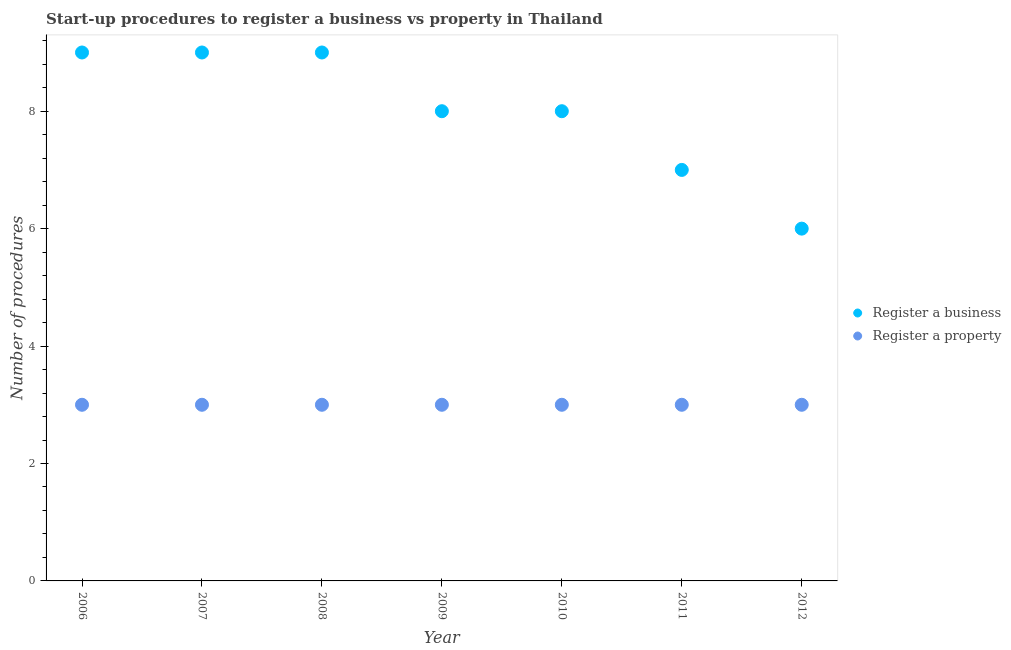What is the number of procedures to register a business in 2009?
Make the answer very short. 8. Across all years, what is the maximum number of procedures to register a property?
Ensure brevity in your answer.  3. Across all years, what is the minimum number of procedures to register a property?
Give a very brief answer. 3. In which year was the number of procedures to register a business maximum?
Provide a short and direct response. 2006. What is the total number of procedures to register a business in the graph?
Offer a terse response. 56. What is the difference between the number of procedures to register a business in 2008 and that in 2012?
Ensure brevity in your answer.  3. What is the difference between the number of procedures to register a property in 2007 and the number of procedures to register a business in 2006?
Keep it short and to the point. -6. In the year 2011, what is the difference between the number of procedures to register a business and number of procedures to register a property?
Ensure brevity in your answer.  4. In how many years, is the number of procedures to register a business greater than 7.6?
Keep it short and to the point. 5. What is the ratio of the number of procedures to register a business in 2010 to that in 2012?
Offer a terse response. 1.33. Is the number of procedures to register a business in 2007 less than that in 2008?
Make the answer very short. No. Is the difference between the number of procedures to register a business in 2006 and 2012 greater than the difference between the number of procedures to register a property in 2006 and 2012?
Your response must be concise. Yes. What is the difference between the highest and the second highest number of procedures to register a business?
Keep it short and to the point. 0. What is the difference between the highest and the lowest number of procedures to register a property?
Your answer should be compact. 0. In how many years, is the number of procedures to register a property greater than the average number of procedures to register a property taken over all years?
Your answer should be compact. 0. Is the sum of the number of procedures to register a property in 2008 and 2010 greater than the maximum number of procedures to register a business across all years?
Keep it short and to the point. No. Is the number of procedures to register a business strictly greater than the number of procedures to register a property over the years?
Make the answer very short. Yes. Is the number of procedures to register a property strictly less than the number of procedures to register a business over the years?
Your answer should be compact. Yes. How many dotlines are there?
Keep it short and to the point. 2. What is the difference between two consecutive major ticks on the Y-axis?
Ensure brevity in your answer.  2. Are the values on the major ticks of Y-axis written in scientific E-notation?
Give a very brief answer. No. Does the graph contain grids?
Keep it short and to the point. No. How many legend labels are there?
Your response must be concise. 2. How are the legend labels stacked?
Your answer should be very brief. Vertical. What is the title of the graph?
Your response must be concise. Start-up procedures to register a business vs property in Thailand. Does "Private creditors" appear as one of the legend labels in the graph?
Provide a short and direct response. No. What is the label or title of the Y-axis?
Provide a short and direct response. Number of procedures. What is the Number of procedures of Register a business in 2006?
Provide a succinct answer. 9. What is the Number of procedures of Register a property in 2007?
Offer a very short reply. 3. What is the Number of procedures of Register a business in 2008?
Your answer should be compact. 9. What is the Number of procedures in Register a property in 2009?
Ensure brevity in your answer.  3. What is the Number of procedures in Register a business in 2010?
Make the answer very short. 8. What is the Number of procedures in Register a property in 2010?
Keep it short and to the point. 3. What is the Number of procedures of Register a business in 2011?
Make the answer very short. 7. What is the Number of procedures of Register a property in 2012?
Your response must be concise. 3. Across all years, what is the maximum Number of procedures of Register a business?
Keep it short and to the point. 9. Across all years, what is the maximum Number of procedures of Register a property?
Make the answer very short. 3. Across all years, what is the minimum Number of procedures in Register a business?
Your response must be concise. 6. What is the total Number of procedures in Register a business in the graph?
Your answer should be very brief. 56. What is the total Number of procedures in Register a property in the graph?
Make the answer very short. 21. What is the difference between the Number of procedures in Register a property in 2006 and that in 2007?
Offer a very short reply. 0. What is the difference between the Number of procedures of Register a business in 2006 and that in 2008?
Ensure brevity in your answer.  0. What is the difference between the Number of procedures in Register a property in 2006 and that in 2008?
Your answer should be compact. 0. What is the difference between the Number of procedures in Register a business in 2006 and that in 2009?
Offer a terse response. 1. What is the difference between the Number of procedures in Register a property in 2006 and that in 2009?
Your answer should be compact. 0. What is the difference between the Number of procedures in Register a property in 2006 and that in 2010?
Your answer should be very brief. 0. What is the difference between the Number of procedures in Register a business in 2007 and that in 2008?
Give a very brief answer. 0. What is the difference between the Number of procedures in Register a property in 2007 and that in 2010?
Keep it short and to the point. 0. What is the difference between the Number of procedures of Register a property in 2007 and that in 2011?
Your response must be concise. 0. What is the difference between the Number of procedures of Register a business in 2008 and that in 2010?
Your answer should be compact. 1. What is the difference between the Number of procedures of Register a business in 2008 and that in 2011?
Your answer should be very brief. 2. What is the difference between the Number of procedures in Register a business in 2008 and that in 2012?
Keep it short and to the point. 3. What is the difference between the Number of procedures of Register a property in 2008 and that in 2012?
Provide a short and direct response. 0. What is the difference between the Number of procedures of Register a business in 2009 and that in 2010?
Ensure brevity in your answer.  0. What is the difference between the Number of procedures in Register a property in 2009 and that in 2010?
Make the answer very short. 0. What is the difference between the Number of procedures of Register a property in 2009 and that in 2011?
Offer a very short reply. 0. What is the difference between the Number of procedures of Register a business in 2009 and that in 2012?
Offer a very short reply. 2. What is the difference between the Number of procedures in Register a property in 2010 and that in 2011?
Make the answer very short. 0. What is the difference between the Number of procedures in Register a business in 2006 and the Number of procedures in Register a property in 2007?
Give a very brief answer. 6. What is the difference between the Number of procedures in Register a business in 2006 and the Number of procedures in Register a property in 2008?
Keep it short and to the point. 6. What is the difference between the Number of procedures in Register a business in 2006 and the Number of procedures in Register a property in 2010?
Your answer should be very brief. 6. What is the difference between the Number of procedures in Register a business in 2007 and the Number of procedures in Register a property in 2008?
Offer a very short reply. 6. What is the difference between the Number of procedures of Register a business in 2008 and the Number of procedures of Register a property in 2010?
Your answer should be compact. 6. What is the difference between the Number of procedures of Register a business in 2008 and the Number of procedures of Register a property in 2012?
Make the answer very short. 6. What is the difference between the Number of procedures in Register a business in 2010 and the Number of procedures in Register a property in 2011?
Provide a short and direct response. 5. What is the average Number of procedures in Register a property per year?
Provide a short and direct response. 3. In the year 2006, what is the difference between the Number of procedures in Register a business and Number of procedures in Register a property?
Your answer should be compact. 6. In the year 2008, what is the difference between the Number of procedures in Register a business and Number of procedures in Register a property?
Keep it short and to the point. 6. In the year 2009, what is the difference between the Number of procedures of Register a business and Number of procedures of Register a property?
Offer a very short reply. 5. In the year 2010, what is the difference between the Number of procedures of Register a business and Number of procedures of Register a property?
Provide a succinct answer. 5. In the year 2011, what is the difference between the Number of procedures in Register a business and Number of procedures in Register a property?
Your response must be concise. 4. In the year 2012, what is the difference between the Number of procedures in Register a business and Number of procedures in Register a property?
Your answer should be very brief. 3. What is the ratio of the Number of procedures in Register a business in 2006 to that in 2007?
Ensure brevity in your answer.  1. What is the ratio of the Number of procedures in Register a property in 2006 to that in 2008?
Make the answer very short. 1. What is the ratio of the Number of procedures of Register a property in 2006 to that in 2009?
Ensure brevity in your answer.  1. What is the ratio of the Number of procedures in Register a business in 2006 to that in 2010?
Provide a short and direct response. 1.12. What is the ratio of the Number of procedures in Register a property in 2006 to that in 2011?
Offer a very short reply. 1. What is the ratio of the Number of procedures in Register a property in 2007 to that in 2008?
Make the answer very short. 1. What is the ratio of the Number of procedures in Register a property in 2007 to that in 2010?
Give a very brief answer. 1. What is the ratio of the Number of procedures in Register a business in 2007 to that in 2012?
Keep it short and to the point. 1.5. What is the ratio of the Number of procedures of Register a business in 2008 to that in 2009?
Your response must be concise. 1.12. What is the ratio of the Number of procedures of Register a property in 2008 to that in 2010?
Make the answer very short. 1. What is the ratio of the Number of procedures of Register a business in 2008 to that in 2011?
Provide a short and direct response. 1.29. What is the ratio of the Number of procedures of Register a business in 2009 to that in 2010?
Provide a short and direct response. 1. What is the ratio of the Number of procedures of Register a property in 2009 to that in 2010?
Keep it short and to the point. 1. What is the ratio of the Number of procedures of Register a business in 2009 to that in 2011?
Offer a very short reply. 1.14. What is the ratio of the Number of procedures of Register a business in 2010 to that in 2011?
Make the answer very short. 1.14. What is the ratio of the Number of procedures of Register a business in 2010 to that in 2012?
Give a very brief answer. 1.33. What is the difference between the highest and the second highest Number of procedures in Register a business?
Provide a succinct answer. 0. What is the difference between the highest and the second highest Number of procedures in Register a property?
Your answer should be compact. 0. What is the difference between the highest and the lowest Number of procedures of Register a business?
Keep it short and to the point. 3. What is the difference between the highest and the lowest Number of procedures of Register a property?
Offer a terse response. 0. 